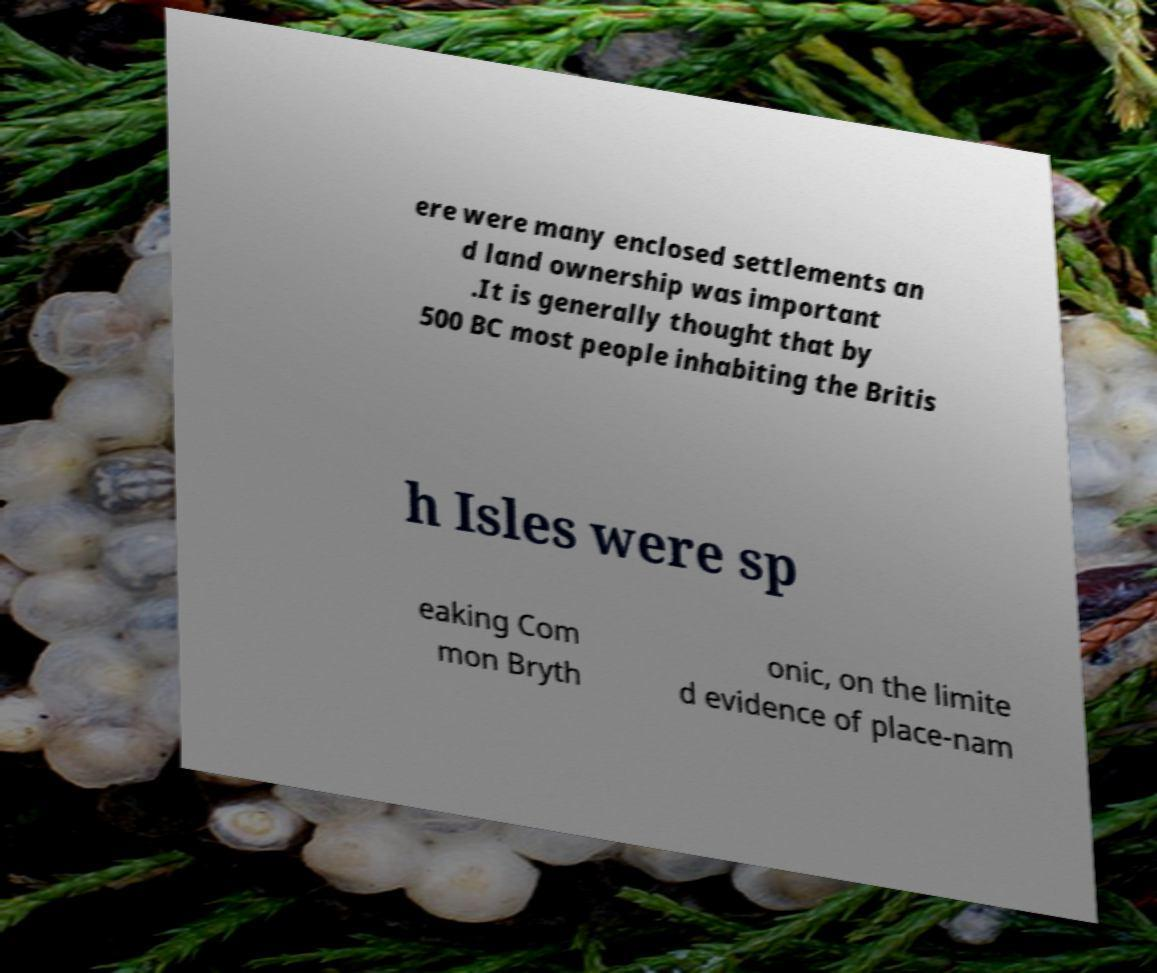I need the written content from this picture converted into text. Can you do that? ere were many enclosed settlements an d land ownership was important .It is generally thought that by 500 BC most people inhabiting the Britis h Isles were sp eaking Com mon Bryth onic, on the limite d evidence of place-nam 